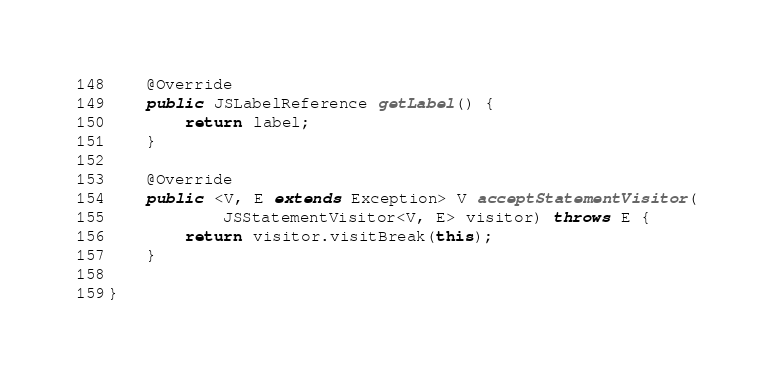Convert code to text. <code><loc_0><loc_0><loc_500><loc_500><_Java_>
	@Override
	public JSLabelReference getLabel() {
		return label;
	}

	@Override
	public <V, E extends Exception> V acceptStatementVisitor(
			JSStatementVisitor<V, E> visitor) throws E {
		return visitor.visitBreak(this);
	}

}
</code> 